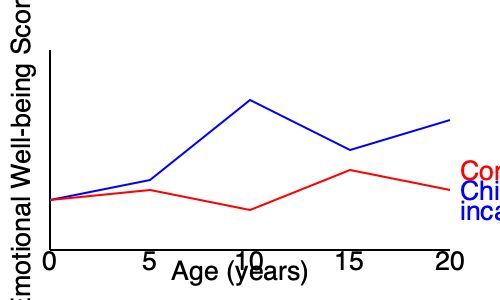Based on the line graph, at what age does the emotional well-being of children with an incarcerated parent appear to be most significantly impacted compared to the control group? Explain the potential reasons for this divergence and its implications for intervention strategies. To answer this question, we need to analyze the graph and identify the point of greatest divergence between the two lines:

1. The blue line represents children with an incarcerated parent, while the red line represents the control group.

2. Examine the lines at each age point:
   - At age 0: Both groups start at similar levels
   - At age 5: Slight divergence, but still relatively close
   - At age 10: Significant divergence, with the blue line dropping sharply
   - At age 15: The gap narrows slightly
   - At age 20: The gap remains, but is not as wide as at age 10

3. The most significant divergence occurs at age 10, where the emotional well-being score for children with incarcerated parents drops dramatically compared to the control group.

4. Potential reasons for this divergence at age 10:
   a) Increased awareness and understanding of the parent's absence
   b) Stigma and social challenges in school settings
   c) Onset of puberty and heightened emotional sensitivity
   d) Increased family responsibilities or stress

5. Implications for intervention strategies:
   a) Focus on early intervention programs targeting children aged 8-12
   b) Develop school-based support systems for this age group
   c) Provide counseling and emotional support tailored to pre-teens
   d) Implement family strengthening programs to address the unique challenges faced during this period

The sharp divergence at age 10 suggests that this is a critical period for intervention to mitigate the long-term emotional impact of parental incarceration on child development.
Answer: Age 10, due to heightened awareness and social challenges, suggesting a need for targeted interventions for pre-teens. 